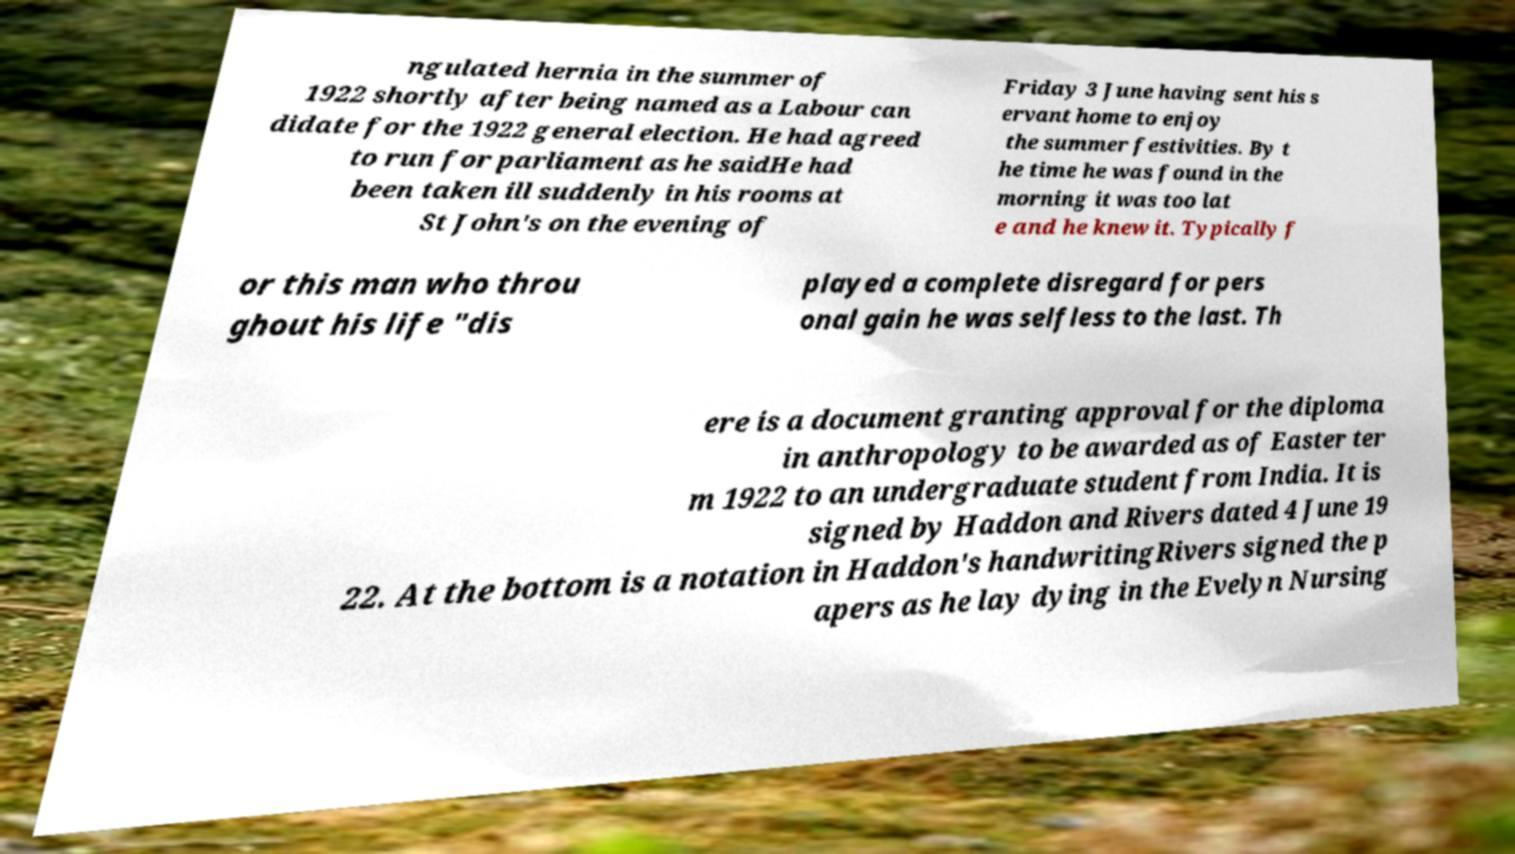I need the written content from this picture converted into text. Can you do that? ngulated hernia in the summer of 1922 shortly after being named as a Labour can didate for the 1922 general election. He had agreed to run for parliament as he saidHe had been taken ill suddenly in his rooms at St John's on the evening of Friday 3 June having sent his s ervant home to enjoy the summer festivities. By t he time he was found in the morning it was too lat e and he knew it. Typically f or this man who throu ghout his life "dis played a complete disregard for pers onal gain he was selfless to the last. Th ere is a document granting approval for the diploma in anthropology to be awarded as of Easter ter m 1922 to an undergraduate student from India. It is signed by Haddon and Rivers dated 4 June 19 22. At the bottom is a notation in Haddon's handwritingRivers signed the p apers as he lay dying in the Evelyn Nursing 